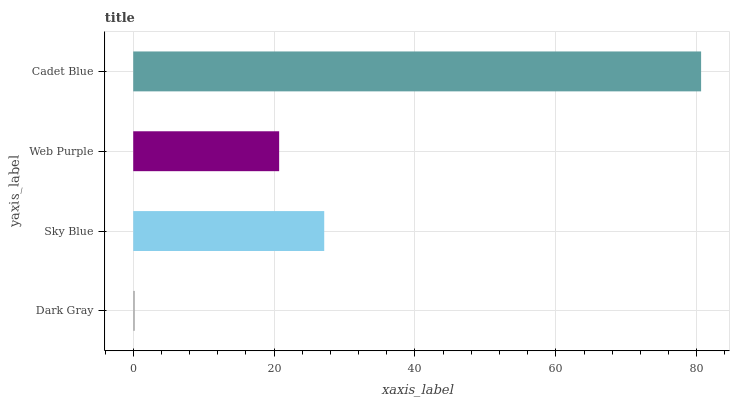Is Dark Gray the minimum?
Answer yes or no. Yes. Is Cadet Blue the maximum?
Answer yes or no. Yes. Is Sky Blue the minimum?
Answer yes or no. No. Is Sky Blue the maximum?
Answer yes or no. No. Is Sky Blue greater than Dark Gray?
Answer yes or no. Yes. Is Dark Gray less than Sky Blue?
Answer yes or no. Yes. Is Dark Gray greater than Sky Blue?
Answer yes or no. No. Is Sky Blue less than Dark Gray?
Answer yes or no. No. Is Sky Blue the high median?
Answer yes or no. Yes. Is Web Purple the low median?
Answer yes or no. Yes. Is Cadet Blue the high median?
Answer yes or no. No. Is Sky Blue the low median?
Answer yes or no. No. 